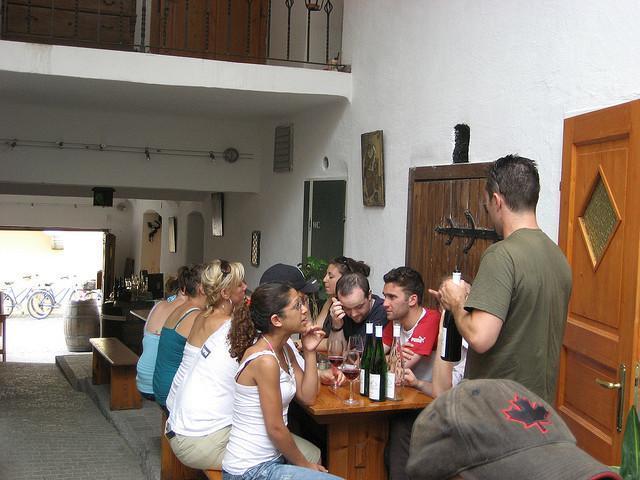How many people are in the picture?
Give a very brief answer. 9. How many beds are in the photo?
Give a very brief answer. 0. 